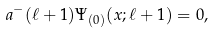Convert formula to latex. <formula><loc_0><loc_0><loc_500><loc_500>a ^ { - } ( \ell + 1 ) \Psi _ { ( 0 ) } ( x ; \ell + 1 ) = 0 ,</formula> 